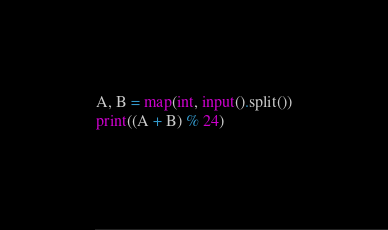<code> <loc_0><loc_0><loc_500><loc_500><_Python_>A, B = map(int, input().split())
print((A + B) % 24)</code> 